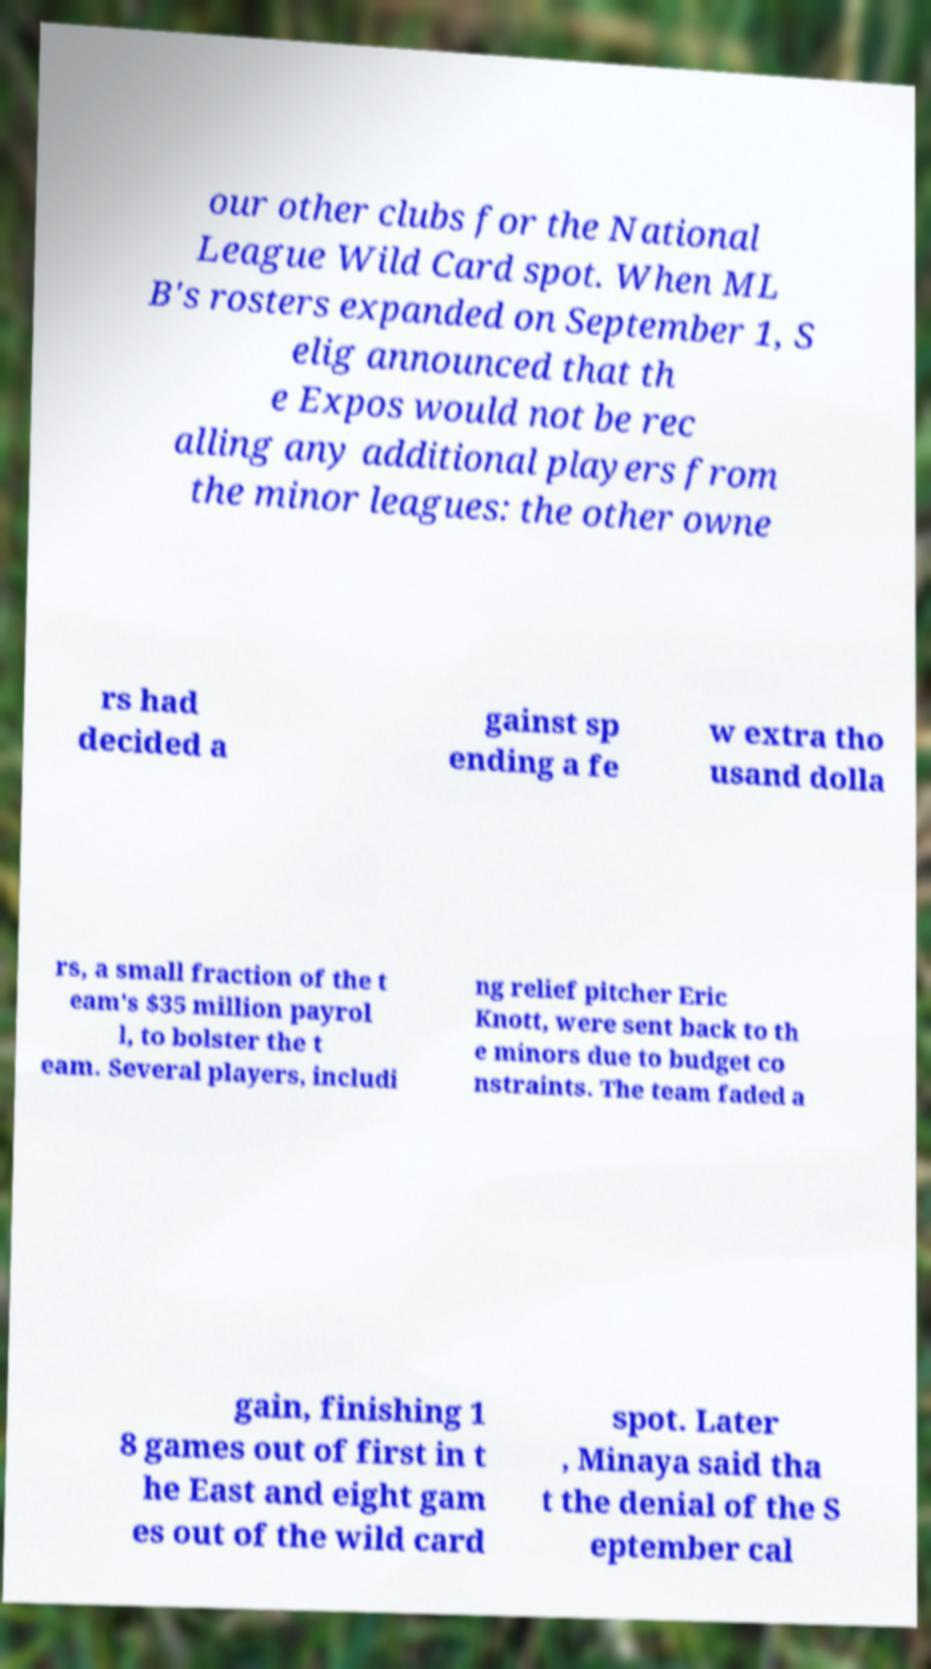Can you read and provide the text displayed in the image?This photo seems to have some interesting text. Can you extract and type it out for me? our other clubs for the National League Wild Card spot. When ML B's rosters expanded on September 1, S elig announced that th e Expos would not be rec alling any additional players from the minor leagues: the other owne rs had decided a gainst sp ending a fe w extra tho usand dolla rs, a small fraction of the t eam's $35 million payrol l, to bolster the t eam. Several players, includi ng relief pitcher Eric Knott, were sent back to th e minors due to budget co nstraints. The team faded a gain, finishing 1 8 games out of first in t he East and eight gam es out of the wild card spot. Later , Minaya said tha t the denial of the S eptember cal 